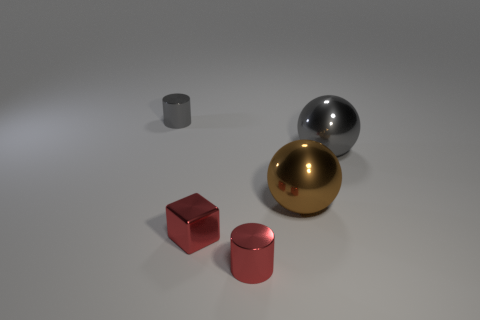Add 2 tiny gray things. How many objects exist? 7 Subtract 1 brown spheres. How many objects are left? 4 Subtract all spheres. How many objects are left? 3 Subtract 1 cubes. How many cubes are left? 0 Subtract all green spheres. Subtract all green cylinders. How many spheres are left? 2 Subtract all gray cubes. How many cyan cylinders are left? 0 Subtract all red objects. Subtract all tiny metal cylinders. How many objects are left? 1 Add 4 tiny metal objects. How many tiny metal objects are left? 7 Add 1 gray shiny things. How many gray shiny things exist? 3 